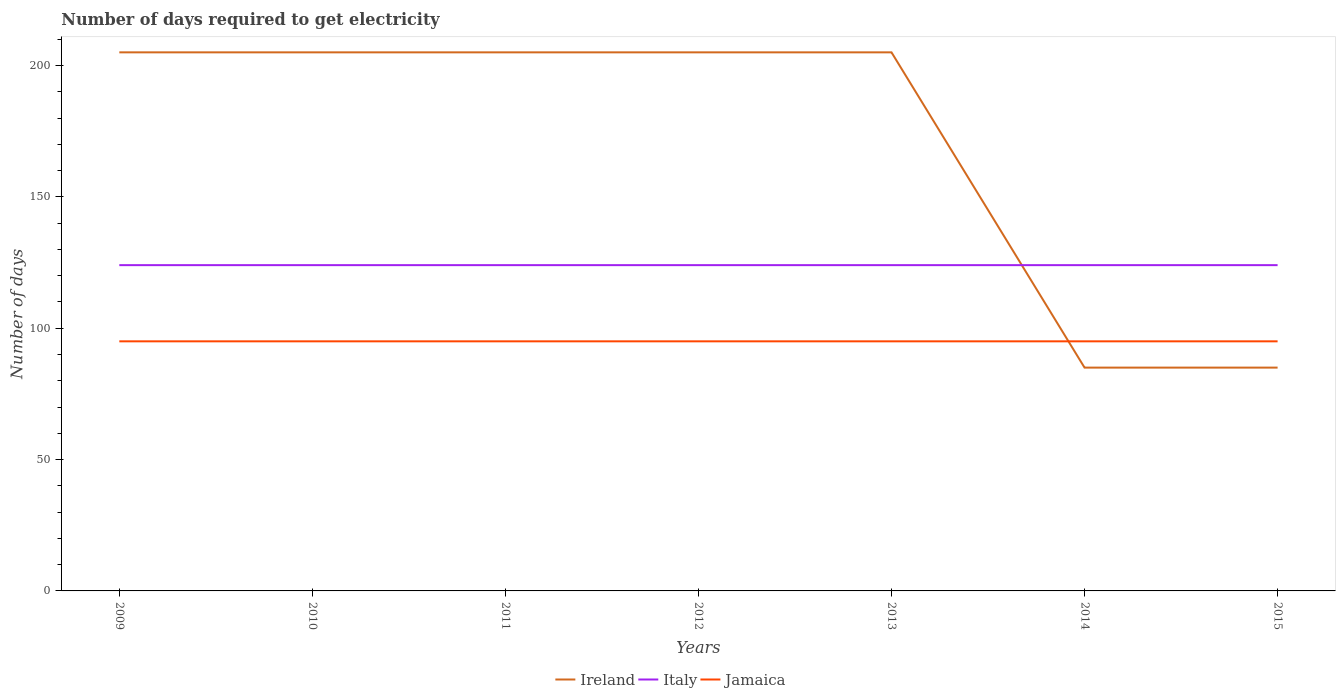Does the line corresponding to Italy intersect with the line corresponding to Jamaica?
Your answer should be compact. No. Is the number of lines equal to the number of legend labels?
Keep it short and to the point. Yes. Across all years, what is the maximum number of days required to get electricity in in Jamaica?
Provide a succinct answer. 95. What is the total number of days required to get electricity in in Jamaica in the graph?
Offer a terse response. 0. What is the difference between the highest and the second highest number of days required to get electricity in in Ireland?
Keep it short and to the point. 120. What is the difference between the highest and the lowest number of days required to get electricity in in Italy?
Your answer should be very brief. 0. How many years are there in the graph?
Offer a terse response. 7. Does the graph contain grids?
Your answer should be compact. No. Where does the legend appear in the graph?
Your answer should be compact. Bottom center. How many legend labels are there?
Your response must be concise. 3. How are the legend labels stacked?
Offer a very short reply. Horizontal. What is the title of the graph?
Your response must be concise. Number of days required to get electricity. Does "Hungary" appear as one of the legend labels in the graph?
Provide a short and direct response. No. What is the label or title of the X-axis?
Make the answer very short. Years. What is the label or title of the Y-axis?
Your answer should be very brief. Number of days. What is the Number of days in Ireland in 2009?
Provide a succinct answer. 205. What is the Number of days in Italy in 2009?
Ensure brevity in your answer.  124. What is the Number of days in Jamaica in 2009?
Your response must be concise. 95. What is the Number of days in Ireland in 2010?
Provide a succinct answer. 205. What is the Number of days in Italy in 2010?
Offer a very short reply. 124. What is the Number of days of Ireland in 2011?
Provide a short and direct response. 205. What is the Number of days of Italy in 2011?
Provide a short and direct response. 124. What is the Number of days in Ireland in 2012?
Provide a short and direct response. 205. What is the Number of days in Italy in 2012?
Offer a very short reply. 124. What is the Number of days of Jamaica in 2012?
Ensure brevity in your answer.  95. What is the Number of days in Ireland in 2013?
Your answer should be very brief. 205. What is the Number of days in Italy in 2013?
Provide a short and direct response. 124. What is the Number of days of Jamaica in 2013?
Your response must be concise. 95. What is the Number of days in Ireland in 2014?
Your answer should be very brief. 85. What is the Number of days in Italy in 2014?
Your answer should be very brief. 124. What is the Number of days in Jamaica in 2014?
Make the answer very short. 95. What is the Number of days in Italy in 2015?
Ensure brevity in your answer.  124. What is the Number of days in Jamaica in 2015?
Offer a terse response. 95. Across all years, what is the maximum Number of days in Ireland?
Provide a succinct answer. 205. Across all years, what is the maximum Number of days in Italy?
Give a very brief answer. 124. Across all years, what is the minimum Number of days in Italy?
Your answer should be compact. 124. Across all years, what is the minimum Number of days of Jamaica?
Ensure brevity in your answer.  95. What is the total Number of days of Ireland in the graph?
Keep it short and to the point. 1195. What is the total Number of days of Italy in the graph?
Offer a very short reply. 868. What is the total Number of days in Jamaica in the graph?
Your answer should be compact. 665. What is the difference between the Number of days of Italy in 2009 and that in 2010?
Offer a very short reply. 0. What is the difference between the Number of days in Italy in 2009 and that in 2011?
Offer a very short reply. 0. What is the difference between the Number of days of Jamaica in 2009 and that in 2011?
Your answer should be very brief. 0. What is the difference between the Number of days in Italy in 2009 and that in 2012?
Give a very brief answer. 0. What is the difference between the Number of days in Jamaica in 2009 and that in 2012?
Provide a succinct answer. 0. What is the difference between the Number of days of Ireland in 2009 and that in 2013?
Your answer should be compact. 0. What is the difference between the Number of days in Jamaica in 2009 and that in 2013?
Offer a terse response. 0. What is the difference between the Number of days of Ireland in 2009 and that in 2014?
Give a very brief answer. 120. What is the difference between the Number of days of Jamaica in 2009 and that in 2014?
Your answer should be compact. 0. What is the difference between the Number of days of Ireland in 2009 and that in 2015?
Your answer should be compact. 120. What is the difference between the Number of days in Jamaica in 2009 and that in 2015?
Provide a short and direct response. 0. What is the difference between the Number of days in Ireland in 2010 and that in 2011?
Ensure brevity in your answer.  0. What is the difference between the Number of days in Jamaica in 2010 and that in 2012?
Provide a short and direct response. 0. What is the difference between the Number of days of Italy in 2010 and that in 2013?
Provide a succinct answer. 0. What is the difference between the Number of days of Jamaica in 2010 and that in 2013?
Your answer should be compact. 0. What is the difference between the Number of days of Ireland in 2010 and that in 2014?
Ensure brevity in your answer.  120. What is the difference between the Number of days in Italy in 2010 and that in 2014?
Ensure brevity in your answer.  0. What is the difference between the Number of days of Ireland in 2010 and that in 2015?
Your answer should be compact. 120. What is the difference between the Number of days of Italy in 2010 and that in 2015?
Keep it short and to the point. 0. What is the difference between the Number of days in Jamaica in 2010 and that in 2015?
Your answer should be compact. 0. What is the difference between the Number of days in Ireland in 2011 and that in 2012?
Make the answer very short. 0. What is the difference between the Number of days of Italy in 2011 and that in 2012?
Make the answer very short. 0. What is the difference between the Number of days of Jamaica in 2011 and that in 2012?
Your answer should be very brief. 0. What is the difference between the Number of days of Ireland in 2011 and that in 2014?
Ensure brevity in your answer.  120. What is the difference between the Number of days in Italy in 2011 and that in 2014?
Your answer should be compact. 0. What is the difference between the Number of days in Jamaica in 2011 and that in 2014?
Your response must be concise. 0. What is the difference between the Number of days in Ireland in 2011 and that in 2015?
Give a very brief answer. 120. What is the difference between the Number of days of Italy in 2012 and that in 2013?
Your answer should be compact. 0. What is the difference between the Number of days in Jamaica in 2012 and that in 2013?
Your response must be concise. 0. What is the difference between the Number of days of Ireland in 2012 and that in 2014?
Provide a short and direct response. 120. What is the difference between the Number of days of Ireland in 2012 and that in 2015?
Keep it short and to the point. 120. What is the difference between the Number of days in Italy in 2012 and that in 2015?
Give a very brief answer. 0. What is the difference between the Number of days of Jamaica in 2012 and that in 2015?
Your answer should be very brief. 0. What is the difference between the Number of days in Ireland in 2013 and that in 2014?
Ensure brevity in your answer.  120. What is the difference between the Number of days in Ireland in 2013 and that in 2015?
Keep it short and to the point. 120. What is the difference between the Number of days in Italy in 2013 and that in 2015?
Your answer should be very brief. 0. What is the difference between the Number of days of Ireland in 2014 and that in 2015?
Your response must be concise. 0. What is the difference between the Number of days in Italy in 2014 and that in 2015?
Give a very brief answer. 0. What is the difference between the Number of days in Ireland in 2009 and the Number of days in Italy in 2010?
Make the answer very short. 81. What is the difference between the Number of days of Ireland in 2009 and the Number of days of Jamaica in 2010?
Your answer should be compact. 110. What is the difference between the Number of days in Italy in 2009 and the Number of days in Jamaica in 2010?
Give a very brief answer. 29. What is the difference between the Number of days in Ireland in 2009 and the Number of days in Jamaica in 2011?
Your response must be concise. 110. What is the difference between the Number of days in Italy in 2009 and the Number of days in Jamaica in 2011?
Your answer should be compact. 29. What is the difference between the Number of days of Ireland in 2009 and the Number of days of Jamaica in 2012?
Give a very brief answer. 110. What is the difference between the Number of days of Italy in 2009 and the Number of days of Jamaica in 2012?
Provide a short and direct response. 29. What is the difference between the Number of days in Ireland in 2009 and the Number of days in Jamaica in 2013?
Provide a succinct answer. 110. What is the difference between the Number of days of Italy in 2009 and the Number of days of Jamaica in 2013?
Provide a succinct answer. 29. What is the difference between the Number of days of Ireland in 2009 and the Number of days of Jamaica in 2014?
Your answer should be compact. 110. What is the difference between the Number of days in Ireland in 2009 and the Number of days in Italy in 2015?
Offer a very short reply. 81. What is the difference between the Number of days in Ireland in 2009 and the Number of days in Jamaica in 2015?
Make the answer very short. 110. What is the difference between the Number of days of Ireland in 2010 and the Number of days of Italy in 2011?
Give a very brief answer. 81. What is the difference between the Number of days in Ireland in 2010 and the Number of days in Jamaica in 2011?
Ensure brevity in your answer.  110. What is the difference between the Number of days in Italy in 2010 and the Number of days in Jamaica in 2011?
Your answer should be very brief. 29. What is the difference between the Number of days in Ireland in 2010 and the Number of days in Jamaica in 2012?
Provide a succinct answer. 110. What is the difference between the Number of days of Ireland in 2010 and the Number of days of Italy in 2013?
Provide a short and direct response. 81. What is the difference between the Number of days in Ireland in 2010 and the Number of days in Jamaica in 2013?
Give a very brief answer. 110. What is the difference between the Number of days of Italy in 2010 and the Number of days of Jamaica in 2013?
Give a very brief answer. 29. What is the difference between the Number of days of Ireland in 2010 and the Number of days of Jamaica in 2014?
Keep it short and to the point. 110. What is the difference between the Number of days in Ireland in 2010 and the Number of days in Italy in 2015?
Your response must be concise. 81. What is the difference between the Number of days of Ireland in 2010 and the Number of days of Jamaica in 2015?
Make the answer very short. 110. What is the difference between the Number of days in Italy in 2010 and the Number of days in Jamaica in 2015?
Your response must be concise. 29. What is the difference between the Number of days of Ireland in 2011 and the Number of days of Jamaica in 2012?
Provide a succinct answer. 110. What is the difference between the Number of days of Italy in 2011 and the Number of days of Jamaica in 2012?
Ensure brevity in your answer.  29. What is the difference between the Number of days of Ireland in 2011 and the Number of days of Italy in 2013?
Offer a terse response. 81. What is the difference between the Number of days in Ireland in 2011 and the Number of days in Jamaica in 2013?
Offer a very short reply. 110. What is the difference between the Number of days of Italy in 2011 and the Number of days of Jamaica in 2013?
Ensure brevity in your answer.  29. What is the difference between the Number of days in Ireland in 2011 and the Number of days in Italy in 2014?
Provide a short and direct response. 81. What is the difference between the Number of days of Ireland in 2011 and the Number of days of Jamaica in 2014?
Offer a terse response. 110. What is the difference between the Number of days of Ireland in 2011 and the Number of days of Italy in 2015?
Provide a short and direct response. 81. What is the difference between the Number of days of Ireland in 2011 and the Number of days of Jamaica in 2015?
Offer a terse response. 110. What is the difference between the Number of days of Italy in 2011 and the Number of days of Jamaica in 2015?
Your answer should be very brief. 29. What is the difference between the Number of days of Ireland in 2012 and the Number of days of Jamaica in 2013?
Offer a terse response. 110. What is the difference between the Number of days in Ireland in 2012 and the Number of days in Italy in 2014?
Your answer should be compact. 81. What is the difference between the Number of days in Ireland in 2012 and the Number of days in Jamaica in 2014?
Your response must be concise. 110. What is the difference between the Number of days of Italy in 2012 and the Number of days of Jamaica in 2014?
Offer a very short reply. 29. What is the difference between the Number of days of Ireland in 2012 and the Number of days of Jamaica in 2015?
Give a very brief answer. 110. What is the difference between the Number of days in Italy in 2012 and the Number of days in Jamaica in 2015?
Your response must be concise. 29. What is the difference between the Number of days of Ireland in 2013 and the Number of days of Jamaica in 2014?
Your answer should be very brief. 110. What is the difference between the Number of days of Italy in 2013 and the Number of days of Jamaica in 2014?
Ensure brevity in your answer.  29. What is the difference between the Number of days in Ireland in 2013 and the Number of days in Jamaica in 2015?
Provide a short and direct response. 110. What is the difference between the Number of days of Italy in 2013 and the Number of days of Jamaica in 2015?
Your answer should be very brief. 29. What is the difference between the Number of days in Ireland in 2014 and the Number of days in Italy in 2015?
Offer a terse response. -39. What is the difference between the Number of days of Ireland in 2014 and the Number of days of Jamaica in 2015?
Offer a terse response. -10. What is the average Number of days in Ireland per year?
Offer a terse response. 170.71. What is the average Number of days of Italy per year?
Give a very brief answer. 124. What is the average Number of days of Jamaica per year?
Provide a succinct answer. 95. In the year 2009, what is the difference between the Number of days of Ireland and Number of days of Jamaica?
Provide a short and direct response. 110. In the year 2009, what is the difference between the Number of days of Italy and Number of days of Jamaica?
Your answer should be compact. 29. In the year 2010, what is the difference between the Number of days of Ireland and Number of days of Italy?
Offer a terse response. 81. In the year 2010, what is the difference between the Number of days of Ireland and Number of days of Jamaica?
Your answer should be compact. 110. In the year 2011, what is the difference between the Number of days of Ireland and Number of days of Jamaica?
Your answer should be very brief. 110. In the year 2011, what is the difference between the Number of days in Italy and Number of days in Jamaica?
Offer a very short reply. 29. In the year 2012, what is the difference between the Number of days in Ireland and Number of days in Italy?
Offer a terse response. 81. In the year 2012, what is the difference between the Number of days in Ireland and Number of days in Jamaica?
Provide a short and direct response. 110. In the year 2012, what is the difference between the Number of days of Italy and Number of days of Jamaica?
Give a very brief answer. 29. In the year 2013, what is the difference between the Number of days of Ireland and Number of days of Jamaica?
Offer a terse response. 110. In the year 2013, what is the difference between the Number of days in Italy and Number of days in Jamaica?
Your answer should be very brief. 29. In the year 2014, what is the difference between the Number of days in Ireland and Number of days in Italy?
Your answer should be compact. -39. In the year 2014, what is the difference between the Number of days in Italy and Number of days in Jamaica?
Your answer should be compact. 29. In the year 2015, what is the difference between the Number of days of Ireland and Number of days of Italy?
Your answer should be compact. -39. In the year 2015, what is the difference between the Number of days in Italy and Number of days in Jamaica?
Your response must be concise. 29. What is the ratio of the Number of days of Jamaica in 2009 to that in 2011?
Provide a short and direct response. 1. What is the ratio of the Number of days in Italy in 2009 to that in 2012?
Offer a terse response. 1. What is the ratio of the Number of days in Jamaica in 2009 to that in 2013?
Provide a short and direct response. 1. What is the ratio of the Number of days of Ireland in 2009 to that in 2014?
Keep it short and to the point. 2.41. What is the ratio of the Number of days of Italy in 2009 to that in 2014?
Your answer should be very brief. 1. What is the ratio of the Number of days in Ireland in 2009 to that in 2015?
Ensure brevity in your answer.  2.41. What is the ratio of the Number of days of Italy in 2009 to that in 2015?
Your response must be concise. 1. What is the ratio of the Number of days of Jamaica in 2009 to that in 2015?
Make the answer very short. 1. What is the ratio of the Number of days of Jamaica in 2010 to that in 2011?
Make the answer very short. 1. What is the ratio of the Number of days of Ireland in 2010 to that in 2012?
Give a very brief answer. 1. What is the ratio of the Number of days in Italy in 2010 to that in 2012?
Make the answer very short. 1. What is the ratio of the Number of days of Ireland in 2010 to that in 2013?
Keep it short and to the point. 1. What is the ratio of the Number of days in Ireland in 2010 to that in 2014?
Ensure brevity in your answer.  2.41. What is the ratio of the Number of days of Ireland in 2010 to that in 2015?
Make the answer very short. 2.41. What is the ratio of the Number of days of Italy in 2010 to that in 2015?
Provide a short and direct response. 1. What is the ratio of the Number of days in Jamaica in 2010 to that in 2015?
Ensure brevity in your answer.  1. What is the ratio of the Number of days in Jamaica in 2011 to that in 2012?
Provide a short and direct response. 1. What is the ratio of the Number of days in Ireland in 2011 to that in 2013?
Give a very brief answer. 1. What is the ratio of the Number of days in Ireland in 2011 to that in 2014?
Your response must be concise. 2.41. What is the ratio of the Number of days of Jamaica in 2011 to that in 2014?
Your answer should be very brief. 1. What is the ratio of the Number of days in Ireland in 2011 to that in 2015?
Your answer should be compact. 2.41. What is the ratio of the Number of days in Ireland in 2012 to that in 2013?
Provide a short and direct response. 1. What is the ratio of the Number of days in Italy in 2012 to that in 2013?
Offer a terse response. 1. What is the ratio of the Number of days in Ireland in 2012 to that in 2014?
Your answer should be very brief. 2.41. What is the ratio of the Number of days in Italy in 2012 to that in 2014?
Offer a terse response. 1. What is the ratio of the Number of days of Ireland in 2012 to that in 2015?
Provide a succinct answer. 2.41. What is the ratio of the Number of days in Jamaica in 2012 to that in 2015?
Ensure brevity in your answer.  1. What is the ratio of the Number of days of Ireland in 2013 to that in 2014?
Offer a very short reply. 2.41. What is the ratio of the Number of days of Italy in 2013 to that in 2014?
Ensure brevity in your answer.  1. What is the ratio of the Number of days of Jamaica in 2013 to that in 2014?
Your response must be concise. 1. What is the ratio of the Number of days of Ireland in 2013 to that in 2015?
Your answer should be very brief. 2.41. What is the ratio of the Number of days of Italy in 2013 to that in 2015?
Offer a very short reply. 1. What is the ratio of the Number of days of Jamaica in 2013 to that in 2015?
Make the answer very short. 1. What is the ratio of the Number of days in Ireland in 2014 to that in 2015?
Offer a very short reply. 1. What is the difference between the highest and the second highest Number of days in Jamaica?
Your response must be concise. 0. What is the difference between the highest and the lowest Number of days of Ireland?
Make the answer very short. 120. What is the difference between the highest and the lowest Number of days in Jamaica?
Provide a succinct answer. 0. 